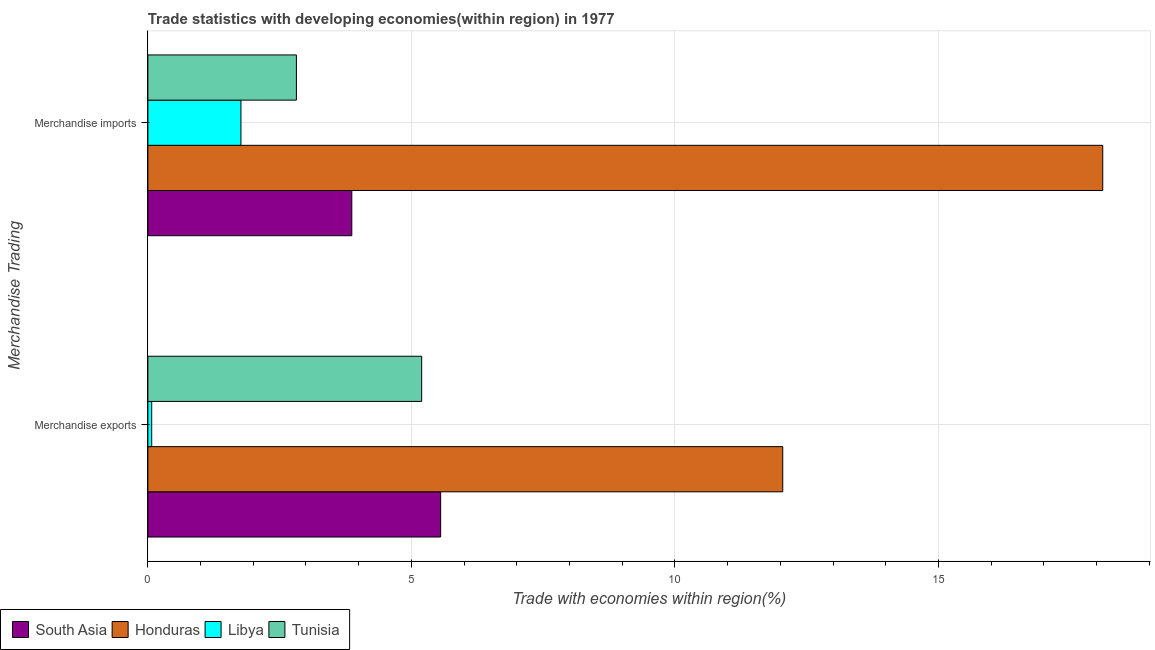How many different coloured bars are there?
Provide a succinct answer. 4. How many groups of bars are there?
Provide a short and direct response. 2. Are the number of bars per tick equal to the number of legend labels?
Your answer should be very brief. Yes. How many bars are there on the 2nd tick from the top?
Make the answer very short. 4. How many bars are there on the 1st tick from the bottom?
Your answer should be compact. 4. What is the label of the 1st group of bars from the top?
Your response must be concise. Merchandise imports. What is the merchandise imports in South Asia?
Ensure brevity in your answer.  3.87. Across all countries, what is the maximum merchandise exports?
Your answer should be compact. 12.05. Across all countries, what is the minimum merchandise imports?
Your answer should be compact. 1.77. In which country was the merchandise imports maximum?
Your response must be concise. Honduras. In which country was the merchandise imports minimum?
Make the answer very short. Libya. What is the total merchandise exports in the graph?
Provide a short and direct response. 22.87. What is the difference between the merchandise exports in Libya and that in South Asia?
Give a very brief answer. -5.48. What is the difference between the merchandise imports in South Asia and the merchandise exports in Tunisia?
Make the answer very short. -1.33. What is the average merchandise imports per country?
Give a very brief answer. 6.64. What is the difference between the merchandise imports and merchandise exports in Tunisia?
Provide a short and direct response. -2.38. In how many countries, is the merchandise exports greater than 10 %?
Your response must be concise. 1. What is the ratio of the merchandise exports in Tunisia to that in South Asia?
Your answer should be very brief. 0.94. Is the merchandise exports in Tunisia less than that in Honduras?
Offer a terse response. Yes. In how many countries, is the merchandise imports greater than the average merchandise imports taken over all countries?
Give a very brief answer. 1. What does the 3rd bar from the top in Merchandise imports represents?
Keep it short and to the point. Honduras. What does the 3rd bar from the bottom in Merchandise imports represents?
Offer a very short reply. Libya. How many bars are there?
Ensure brevity in your answer.  8. How many countries are there in the graph?
Your answer should be compact. 4. Does the graph contain any zero values?
Make the answer very short. No. Does the graph contain grids?
Make the answer very short. Yes. Where does the legend appear in the graph?
Make the answer very short. Bottom left. What is the title of the graph?
Offer a very short reply. Trade statistics with developing economies(within region) in 1977. What is the label or title of the X-axis?
Your answer should be compact. Trade with economies within region(%). What is the label or title of the Y-axis?
Offer a very short reply. Merchandise Trading. What is the Trade with economies within region(%) in South Asia in Merchandise exports?
Keep it short and to the point. 5.56. What is the Trade with economies within region(%) in Honduras in Merchandise exports?
Provide a succinct answer. 12.05. What is the Trade with economies within region(%) in Libya in Merchandise exports?
Offer a very short reply. 0.07. What is the Trade with economies within region(%) in Tunisia in Merchandise exports?
Offer a terse response. 5.2. What is the Trade with economies within region(%) of South Asia in Merchandise imports?
Provide a succinct answer. 3.87. What is the Trade with economies within region(%) of Honduras in Merchandise imports?
Keep it short and to the point. 18.12. What is the Trade with economies within region(%) of Libya in Merchandise imports?
Provide a short and direct response. 1.77. What is the Trade with economies within region(%) of Tunisia in Merchandise imports?
Provide a short and direct response. 2.82. Across all Merchandise Trading, what is the maximum Trade with economies within region(%) of South Asia?
Offer a very short reply. 5.56. Across all Merchandise Trading, what is the maximum Trade with economies within region(%) in Honduras?
Make the answer very short. 18.12. Across all Merchandise Trading, what is the maximum Trade with economies within region(%) in Libya?
Provide a short and direct response. 1.77. Across all Merchandise Trading, what is the maximum Trade with economies within region(%) of Tunisia?
Provide a succinct answer. 5.2. Across all Merchandise Trading, what is the minimum Trade with economies within region(%) of South Asia?
Your response must be concise. 3.87. Across all Merchandise Trading, what is the minimum Trade with economies within region(%) in Honduras?
Offer a terse response. 12.05. Across all Merchandise Trading, what is the minimum Trade with economies within region(%) in Libya?
Offer a terse response. 0.07. Across all Merchandise Trading, what is the minimum Trade with economies within region(%) of Tunisia?
Provide a short and direct response. 2.82. What is the total Trade with economies within region(%) of South Asia in the graph?
Offer a very short reply. 9.43. What is the total Trade with economies within region(%) of Honduras in the graph?
Keep it short and to the point. 30.16. What is the total Trade with economies within region(%) of Libya in the graph?
Keep it short and to the point. 1.84. What is the total Trade with economies within region(%) of Tunisia in the graph?
Ensure brevity in your answer.  8.01. What is the difference between the Trade with economies within region(%) of South Asia in Merchandise exports and that in Merchandise imports?
Your response must be concise. 1.69. What is the difference between the Trade with economies within region(%) in Honduras in Merchandise exports and that in Merchandise imports?
Your answer should be very brief. -6.07. What is the difference between the Trade with economies within region(%) of Libya in Merchandise exports and that in Merchandise imports?
Give a very brief answer. -1.69. What is the difference between the Trade with economies within region(%) of Tunisia in Merchandise exports and that in Merchandise imports?
Your answer should be very brief. 2.38. What is the difference between the Trade with economies within region(%) of South Asia in Merchandise exports and the Trade with economies within region(%) of Honduras in Merchandise imports?
Ensure brevity in your answer.  -12.56. What is the difference between the Trade with economies within region(%) of South Asia in Merchandise exports and the Trade with economies within region(%) of Libya in Merchandise imports?
Make the answer very short. 3.79. What is the difference between the Trade with economies within region(%) of South Asia in Merchandise exports and the Trade with economies within region(%) of Tunisia in Merchandise imports?
Give a very brief answer. 2.74. What is the difference between the Trade with economies within region(%) of Honduras in Merchandise exports and the Trade with economies within region(%) of Libya in Merchandise imports?
Provide a succinct answer. 10.28. What is the difference between the Trade with economies within region(%) in Honduras in Merchandise exports and the Trade with economies within region(%) in Tunisia in Merchandise imports?
Keep it short and to the point. 9.23. What is the difference between the Trade with economies within region(%) in Libya in Merchandise exports and the Trade with economies within region(%) in Tunisia in Merchandise imports?
Give a very brief answer. -2.75. What is the average Trade with economies within region(%) of South Asia per Merchandise Trading?
Make the answer very short. 4.71. What is the average Trade with economies within region(%) in Honduras per Merchandise Trading?
Offer a very short reply. 15.08. What is the average Trade with economies within region(%) of Libya per Merchandise Trading?
Offer a terse response. 0.92. What is the average Trade with economies within region(%) in Tunisia per Merchandise Trading?
Give a very brief answer. 4.01. What is the difference between the Trade with economies within region(%) in South Asia and Trade with economies within region(%) in Honduras in Merchandise exports?
Ensure brevity in your answer.  -6.49. What is the difference between the Trade with economies within region(%) of South Asia and Trade with economies within region(%) of Libya in Merchandise exports?
Offer a terse response. 5.48. What is the difference between the Trade with economies within region(%) of South Asia and Trade with economies within region(%) of Tunisia in Merchandise exports?
Make the answer very short. 0.36. What is the difference between the Trade with economies within region(%) of Honduras and Trade with economies within region(%) of Libya in Merchandise exports?
Your answer should be very brief. 11.97. What is the difference between the Trade with economies within region(%) of Honduras and Trade with economies within region(%) of Tunisia in Merchandise exports?
Ensure brevity in your answer.  6.85. What is the difference between the Trade with economies within region(%) in Libya and Trade with economies within region(%) in Tunisia in Merchandise exports?
Your answer should be compact. -5.12. What is the difference between the Trade with economies within region(%) of South Asia and Trade with economies within region(%) of Honduras in Merchandise imports?
Provide a short and direct response. -14.25. What is the difference between the Trade with economies within region(%) in South Asia and Trade with economies within region(%) in Libya in Merchandise imports?
Your answer should be very brief. 2.1. What is the difference between the Trade with economies within region(%) in South Asia and Trade with economies within region(%) in Tunisia in Merchandise imports?
Offer a very short reply. 1.05. What is the difference between the Trade with economies within region(%) of Honduras and Trade with economies within region(%) of Libya in Merchandise imports?
Your response must be concise. 16.35. What is the difference between the Trade with economies within region(%) of Libya and Trade with economies within region(%) of Tunisia in Merchandise imports?
Provide a succinct answer. -1.05. What is the ratio of the Trade with economies within region(%) of South Asia in Merchandise exports to that in Merchandise imports?
Provide a succinct answer. 1.44. What is the ratio of the Trade with economies within region(%) in Honduras in Merchandise exports to that in Merchandise imports?
Your response must be concise. 0.66. What is the ratio of the Trade with economies within region(%) in Libya in Merchandise exports to that in Merchandise imports?
Offer a very short reply. 0.04. What is the ratio of the Trade with economies within region(%) in Tunisia in Merchandise exports to that in Merchandise imports?
Your response must be concise. 1.84. What is the difference between the highest and the second highest Trade with economies within region(%) of South Asia?
Offer a very short reply. 1.69. What is the difference between the highest and the second highest Trade with economies within region(%) in Honduras?
Your answer should be very brief. 6.07. What is the difference between the highest and the second highest Trade with economies within region(%) of Libya?
Provide a short and direct response. 1.69. What is the difference between the highest and the second highest Trade with economies within region(%) of Tunisia?
Make the answer very short. 2.38. What is the difference between the highest and the lowest Trade with economies within region(%) in South Asia?
Provide a succinct answer. 1.69. What is the difference between the highest and the lowest Trade with economies within region(%) of Honduras?
Provide a short and direct response. 6.07. What is the difference between the highest and the lowest Trade with economies within region(%) in Libya?
Keep it short and to the point. 1.69. What is the difference between the highest and the lowest Trade with economies within region(%) of Tunisia?
Provide a short and direct response. 2.38. 